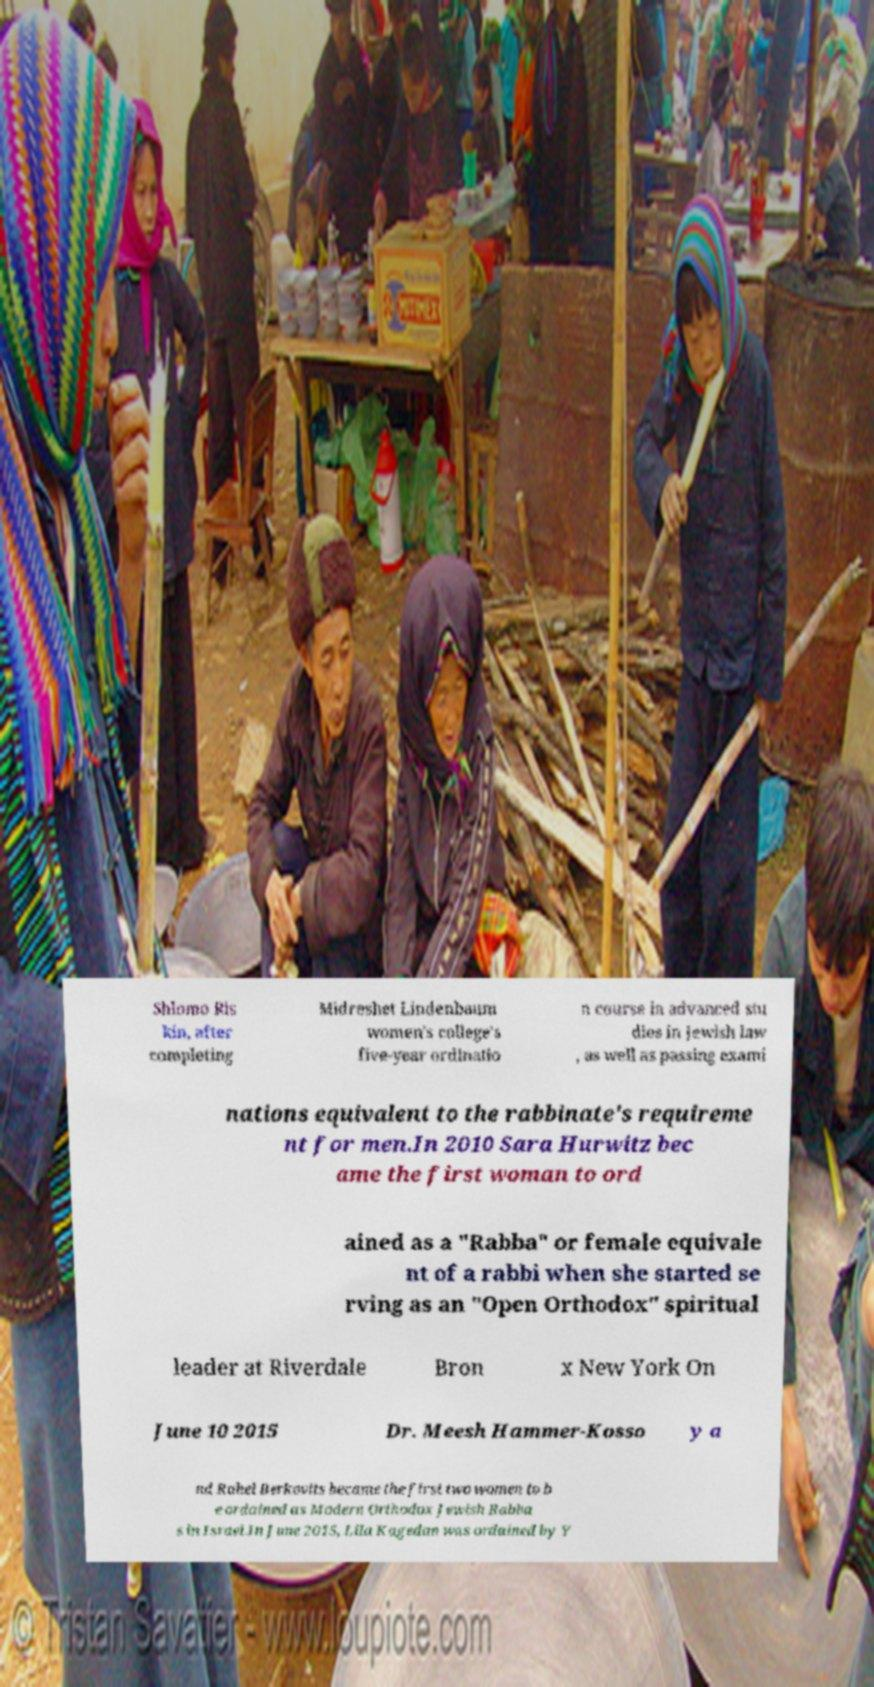Could you assist in decoding the text presented in this image and type it out clearly? Shlomo Ris kin, after completing Midreshet Lindenbaum women's college's five-year ordinatio n course in advanced stu dies in Jewish law , as well as passing exami nations equivalent to the rabbinate's requireme nt for men.In 2010 Sara Hurwitz bec ame the first woman to ord ained as a "Rabba" or female equivale nt of a rabbi when she started se rving as an "Open Orthodox" spiritual leader at Riverdale Bron x New York On June 10 2015 Dr. Meesh Hammer-Kosso y a nd Rahel Berkovits became the first two women to b e ordained as Modern Orthodox Jewish Rabba s in Israel.In June 2015, Lila Kagedan was ordained by Y 